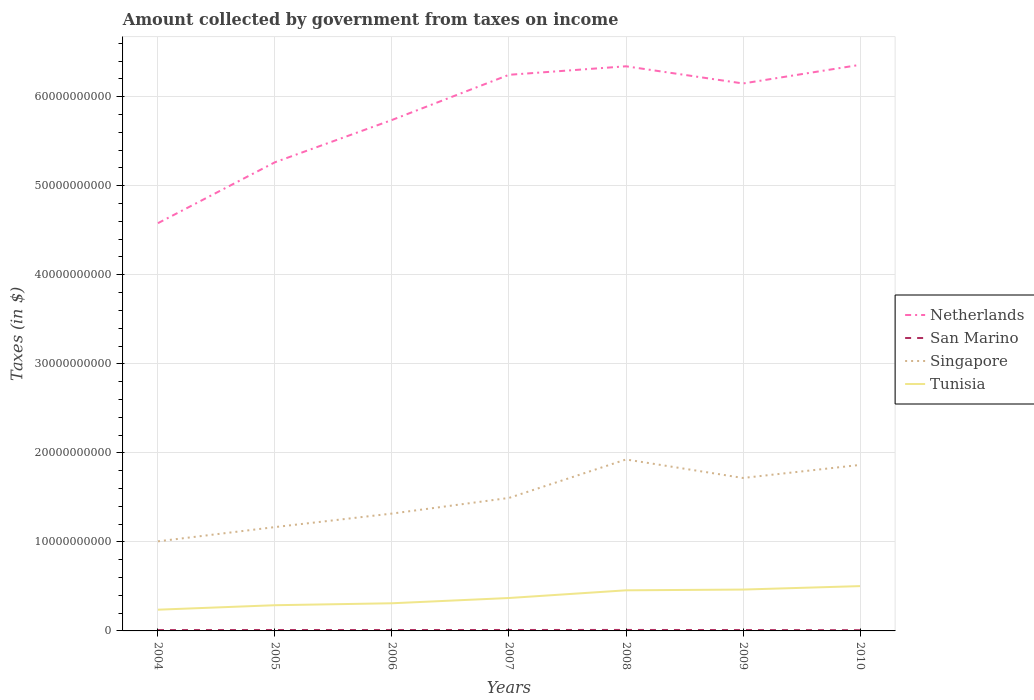Is the number of lines equal to the number of legend labels?
Your answer should be compact. Yes. Across all years, what is the maximum amount collected by government from taxes on income in Tunisia?
Your answer should be very brief. 2.39e+09. What is the total amount collected by government from taxes on income in Netherlands in the graph?
Keep it short and to the point. -9.55e+08. What is the difference between the highest and the second highest amount collected by government from taxes on income in Tunisia?
Make the answer very short. 2.65e+09. Is the amount collected by government from taxes on income in San Marino strictly greater than the amount collected by government from taxes on income in Tunisia over the years?
Your response must be concise. Yes. How many years are there in the graph?
Make the answer very short. 7. Are the values on the major ticks of Y-axis written in scientific E-notation?
Your answer should be compact. No. Does the graph contain any zero values?
Keep it short and to the point. No. How are the legend labels stacked?
Your response must be concise. Vertical. What is the title of the graph?
Offer a very short reply. Amount collected by government from taxes on income. Does "Vietnam" appear as one of the legend labels in the graph?
Your answer should be very brief. No. What is the label or title of the Y-axis?
Keep it short and to the point. Taxes (in $). What is the Taxes (in $) in Netherlands in 2004?
Offer a very short reply. 4.58e+1. What is the Taxes (in $) of San Marino in 2004?
Your answer should be compact. 9.60e+07. What is the Taxes (in $) in Singapore in 2004?
Offer a terse response. 1.01e+1. What is the Taxes (in $) in Tunisia in 2004?
Offer a very short reply. 2.39e+09. What is the Taxes (in $) in Netherlands in 2005?
Give a very brief answer. 5.26e+1. What is the Taxes (in $) of San Marino in 2005?
Ensure brevity in your answer.  1.02e+08. What is the Taxes (in $) of Singapore in 2005?
Your response must be concise. 1.17e+1. What is the Taxes (in $) in Tunisia in 2005?
Offer a terse response. 2.89e+09. What is the Taxes (in $) of Netherlands in 2006?
Give a very brief answer. 5.74e+1. What is the Taxes (in $) in San Marino in 2006?
Provide a short and direct response. 1.00e+08. What is the Taxes (in $) of Singapore in 2006?
Make the answer very short. 1.32e+1. What is the Taxes (in $) of Tunisia in 2006?
Make the answer very short. 3.11e+09. What is the Taxes (in $) in Netherlands in 2007?
Keep it short and to the point. 6.25e+1. What is the Taxes (in $) in San Marino in 2007?
Provide a succinct answer. 1.06e+08. What is the Taxes (in $) in Singapore in 2007?
Offer a very short reply. 1.49e+1. What is the Taxes (in $) of Tunisia in 2007?
Your answer should be very brief. 3.70e+09. What is the Taxes (in $) of Netherlands in 2008?
Ensure brevity in your answer.  6.34e+1. What is the Taxes (in $) in San Marino in 2008?
Offer a terse response. 1.09e+08. What is the Taxes (in $) in Singapore in 2008?
Ensure brevity in your answer.  1.93e+1. What is the Taxes (in $) in Tunisia in 2008?
Your answer should be compact. 4.56e+09. What is the Taxes (in $) in Netherlands in 2009?
Give a very brief answer. 6.15e+1. What is the Taxes (in $) of San Marino in 2009?
Make the answer very short. 9.80e+07. What is the Taxes (in $) in Singapore in 2009?
Offer a very short reply. 1.72e+1. What is the Taxes (in $) of Tunisia in 2009?
Offer a terse response. 4.65e+09. What is the Taxes (in $) in Netherlands in 2010?
Offer a very short reply. 6.36e+1. What is the Taxes (in $) in San Marino in 2010?
Provide a short and direct response. 8.28e+07. What is the Taxes (in $) in Singapore in 2010?
Provide a short and direct response. 1.86e+1. What is the Taxes (in $) of Tunisia in 2010?
Keep it short and to the point. 5.03e+09. Across all years, what is the maximum Taxes (in $) in Netherlands?
Keep it short and to the point. 6.36e+1. Across all years, what is the maximum Taxes (in $) in San Marino?
Your response must be concise. 1.09e+08. Across all years, what is the maximum Taxes (in $) in Singapore?
Give a very brief answer. 1.93e+1. Across all years, what is the maximum Taxes (in $) in Tunisia?
Offer a terse response. 5.03e+09. Across all years, what is the minimum Taxes (in $) of Netherlands?
Provide a succinct answer. 4.58e+1. Across all years, what is the minimum Taxes (in $) of San Marino?
Keep it short and to the point. 8.28e+07. Across all years, what is the minimum Taxes (in $) in Singapore?
Make the answer very short. 1.01e+1. Across all years, what is the minimum Taxes (in $) of Tunisia?
Your answer should be very brief. 2.39e+09. What is the total Taxes (in $) of Netherlands in the graph?
Make the answer very short. 4.07e+11. What is the total Taxes (in $) of San Marino in the graph?
Keep it short and to the point. 6.94e+08. What is the total Taxes (in $) of Singapore in the graph?
Provide a short and direct response. 1.05e+11. What is the total Taxes (in $) in Tunisia in the graph?
Make the answer very short. 2.63e+1. What is the difference between the Taxes (in $) of Netherlands in 2004 and that in 2005?
Give a very brief answer. -6.84e+09. What is the difference between the Taxes (in $) of San Marino in 2004 and that in 2005?
Your response must be concise. -5.80e+06. What is the difference between the Taxes (in $) in Singapore in 2004 and that in 2005?
Your answer should be compact. -1.60e+09. What is the difference between the Taxes (in $) of Tunisia in 2004 and that in 2005?
Make the answer very short. -5.01e+08. What is the difference between the Taxes (in $) of Netherlands in 2004 and that in 2006?
Your response must be concise. -1.16e+1. What is the difference between the Taxes (in $) of San Marino in 2004 and that in 2006?
Offer a very short reply. -4.31e+06. What is the difference between the Taxes (in $) in Singapore in 2004 and that in 2006?
Offer a very short reply. -3.12e+09. What is the difference between the Taxes (in $) in Tunisia in 2004 and that in 2006?
Your response must be concise. -7.22e+08. What is the difference between the Taxes (in $) of Netherlands in 2004 and that in 2007?
Keep it short and to the point. -1.67e+1. What is the difference between the Taxes (in $) of San Marino in 2004 and that in 2007?
Your answer should be compact. -9.60e+06. What is the difference between the Taxes (in $) in Singapore in 2004 and that in 2007?
Your answer should be compact. -4.88e+09. What is the difference between the Taxes (in $) in Tunisia in 2004 and that in 2007?
Ensure brevity in your answer.  -1.31e+09. What is the difference between the Taxes (in $) in Netherlands in 2004 and that in 2008?
Your answer should be compact. -1.76e+1. What is the difference between the Taxes (in $) in San Marino in 2004 and that in 2008?
Offer a very short reply. -1.32e+07. What is the difference between the Taxes (in $) in Singapore in 2004 and that in 2008?
Offer a very short reply. -9.19e+09. What is the difference between the Taxes (in $) in Tunisia in 2004 and that in 2008?
Keep it short and to the point. -2.18e+09. What is the difference between the Taxes (in $) of Netherlands in 2004 and that in 2009?
Provide a short and direct response. -1.57e+1. What is the difference between the Taxes (in $) in San Marino in 2004 and that in 2009?
Give a very brief answer. -2.04e+06. What is the difference between the Taxes (in $) of Singapore in 2004 and that in 2009?
Ensure brevity in your answer.  -7.12e+09. What is the difference between the Taxes (in $) of Tunisia in 2004 and that in 2009?
Your response must be concise. -2.26e+09. What is the difference between the Taxes (in $) in Netherlands in 2004 and that in 2010?
Your answer should be very brief. -1.78e+1. What is the difference between the Taxes (in $) of San Marino in 2004 and that in 2010?
Offer a very short reply. 1.31e+07. What is the difference between the Taxes (in $) of Singapore in 2004 and that in 2010?
Ensure brevity in your answer.  -8.58e+09. What is the difference between the Taxes (in $) in Tunisia in 2004 and that in 2010?
Your answer should be very brief. -2.65e+09. What is the difference between the Taxes (in $) in Netherlands in 2005 and that in 2006?
Your response must be concise. -4.75e+09. What is the difference between the Taxes (in $) of San Marino in 2005 and that in 2006?
Offer a terse response. 1.49e+06. What is the difference between the Taxes (in $) in Singapore in 2005 and that in 2006?
Provide a succinct answer. -1.52e+09. What is the difference between the Taxes (in $) in Tunisia in 2005 and that in 2006?
Make the answer very short. -2.20e+08. What is the difference between the Taxes (in $) in Netherlands in 2005 and that in 2007?
Offer a very short reply. -9.82e+09. What is the difference between the Taxes (in $) of San Marino in 2005 and that in 2007?
Provide a succinct answer. -3.79e+06. What is the difference between the Taxes (in $) of Singapore in 2005 and that in 2007?
Provide a succinct answer. -3.28e+09. What is the difference between the Taxes (in $) in Tunisia in 2005 and that in 2007?
Your answer should be compact. -8.12e+08. What is the difference between the Taxes (in $) in Netherlands in 2005 and that in 2008?
Provide a short and direct response. -1.08e+1. What is the difference between the Taxes (in $) of San Marino in 2005 and that in 2008?
Ensure brevity in your answer.  -7.45e+06. What is the difference between the Taxes (in $) of Singapore in 2005 and that in 2008?
Ensure brevity in your answer.  -7.59e+09. What is the difference between the Taxes (in $) of Tunisia in 2005 and that in 2008?
Offer a terse response. -1.67e+09. What is the difference between the Taxes (in $) of Netherlands in 2005 and that in 2009?
Make the answer very short. -8.85e+09. What is the difference between the Taxes (in $) in San Marino in 2005 and that in 2009?
Your response must be concise. 3.76e+06. What is the difference between the Taxes (in $) of Singapore in 2005 and that in 2009?
Provide a short and direct response. -5.52e+09. What is the difference between the Taxes (in $) in Tunisia in 2005 and that in 2009?
Ensure brevity in your answer.  -1.76e+09. What is the difference between the Taxes (in $) in Netherlands in 2005 and that in 2010?
Your answer should be compact. -1.09e+1. What is the difference between the Taxes (in $) of San Marino in 2005 and that in 2010?
Ensure brevity in your answer.  1.89e+07. What is the difference between the Taxes (in $) in Singapore in 2005 and that in 2010?
Your answer should be very brief. -6.98e+09. What is the difference between the Taxes (in $) in Tunisia in 2005 and that in 2010?
Keep it short and to the point. -2.15e+09. What is the difference between the Taxes (in $) of Netherlands in 2006 and that in 2007?
Keep it short and to the point. -5.07e+09. What is the difference between the Taxes (in $) of San Marino in 2006 and that in 2007?
Provide a short and direct response. -5.29e+06. What is the difference between the Taxes (in $) in Singapore in 2006 and that in 2007?
Provide a short and direct response. -1.76e+09. What is the difference between the Taxes (in $) of Tunisia in 2006 and that in 2007?
Make the answer very short. -5.91e+08. What is the difference between the Taxes (in $) of Netherlands in 2006 and that in 2008?
Provide a succinct answer. -6.03e+09. What is the difference between the Taxes (in $) of San Marino in 2006 and that in 2008?
Make the answer very short. -8.94e+06. What is the difference between the Taxes (in $) in Singapore in 2006 and that in 2008?
Your response must be concise. -6.08e+09. What is the difference between the Taxes (in $) in Tunisia in 2006 and that in 2008?
Provide a succinct answer. -1.45e+09. What is the difference between the Taxes (in $) of Netherlands in 2006 and that in 2009?
Provide a succinct answer. -4.10e+09. What is the difference between the Taxes (in $) in San Marino in 2006 and that in 2009?
Your answer should be compact. 2.27e+06. What is the difference between the Taxes (in $) of Singapore in 2006 and that in 2009?
Your response must be concise. -4.00e+09. What is the difference between the Taxes (in $) of Tunisia in 2006 and that in 2009?
Offer a terse response. -1.54e+09. What is the difference between the Taxes (in $) in Netherlands in 2006 and that in 2010?
Ensure brevity in your answer.  -6.19e+09. What is the difference between the Taxes (in $) of San Marino in 2006 and that in 2010?
Ensure brevity in your answer.  1.74e+07. What is the difference between the Taxes (in $) of Singapore in 2006 and that in 2010?
Your response must be concise. -5.46e+09. What is the difference between the Taxes (in $) in Tunisia in 2006 and that in 2010?
Your answer should be very brief. -1.93e+09. What is the difference between the Taxes (in $) of Netherlands in 2007 and that in 2008?
Your response must be concise. -9.55e+08. What is the difference between the Taxes (in $) in San Marino in 2007 and that in 2008?
Provide a short and direct response. -3.65e+06. What is the difference between the Taxes (in $) in Singapore in 2007 and that in 2008?
Provide a short and direct response. -4.32e+09. What is the difference between the Taxes (in $) of Tunisia in 2007 and that in 2008?
Keep it short and to the point. -8.63e+08. What is the difference between the Taxes (in $) of Netherlands in 2007 and that in 2009?
Offer a very short reply. 9.74e+08. What is the difference between the Taxes (in $) in San Marino in 2007 and that in 2009?
Give a very brief answer. 7.55e+06. What is the difference between the Taxes (in $) in Singapore in 2007 and that in 2009?
Your answer should be compact. -2.24e+09. What is the difference between the Taxes (in $) of Tunisia in 2007 and that in 2009?
Ensure brevity in your answer.  -9.48e+08. What is the difference between the Taxes (in $) in Netherlands in 2007 and that in 2010?
Provide a short and direct response. -1.12e+09. What is the difference between the Taxes (in $) of San Marino in 2007 and that in 2010?
Offer a very short reply. 2.27e+07. What is the difference between the Taxes (in $) of Singapore in 2007 and that in 2010?
Your answer should be very brief. -3.71e+09. What is the difference between the Taxes (in $) of Tunisia in 2007 and that in 2010?
Your answer should be compact. -1.34e+09. What is the difference between the Taxes (in $) in Netherlands in 2008 and that in 2009?
Keep it short and to the point. 1.93e+09. What is the difference between the Taxes (in $) of San Marino in 2008 and that in 2009?
Offer a very short reply. 1.12e+07. What is the difference between the Taxes (in $) in Singapore in 2008 and that in 2009?
Give a very brief answer. 2.08e+09. What is the difference between the Taxes (in $) in Tunisia in 2008 and that in 2009?
Ensure brevity in your answer.  -8.46e+07. What is the difference between the Taxes (in $) in Netherlands in 2008 and that in 2010?
Make the answer very short. -1.63e+08. What is the difference between the Taxes (in $) in San Marino in 2008 and that in 2010?
Offer a terse response. 2.64e+07. What is the difference between the Taxes (in $) of Singapore in 2008 and that in 2010?
Give a very brief answer. 6.11e+08. What is the difference between the Taxes (in $) of Tunisia in 2008 and that in 2010?
Provide a succinct answer. -4.72e+08. What is the difference between the Taxes (in $) in Netherlands in 2009 and that in 2010?
Provide a short and direct response. -2.09e+09. What is the difference between the Taxes (in $) of San Marino in 2009 and that in 2010?
Your response must be concise. 1.52e+07. What is the difference between the Taxes (in $) in Singapore in 2009 and that in 2010?
Offer a very short reply. -1.47e+09. What is the difference between the Taxes (in $) in Tunisia in 2009 and that in 2010?
Give a very brief answer. -3.87e+08. What is the difference between the Taxes (in $) of Netherlands in 2004 and the Taxes (in $) of San Marino in 2005?
Keep it short and to the point. 4.57e+1. What is the difference between the Taxes (in $) in Netherlands in 2004 and the Taxes (in $) in Singapore in 2005?
Offer a very short reply. 3.41e+1. What is the difference between the Taxes (in $) in Netherlands in 2004 and the Taxes (in $) in Tunisia in 2005?
Give a very brief answer. 4.29e+1. What is the difference between the Taxes (in $) of San Marino in 2004 and the Taxes (in $) of Singapore in 2005?
Your answer should be compact. -1.16e+1. What is the difference between the Taxes (in $) in San Marino in 2004 and the Taxes (in $) in Tunisia in 2005?
Your answer should be compact. -2.79e+09. What is the difference between the Taxes (in $) of Singapore in 2004 and the Taxes (in $) of Tunisia in 2005?
Keep it short and to the point. 7.18e+09. What is the difference between the Taxes (in $) of Netherlands in 2004 and the Taxes (in $) of San Marino in 2006?
Provide a succinct answer. 4.57e+1. What is the difference between the Taxes (in $) in Netherlands in 2004 and the Taxes (in $) in Singapore in 2006?
Offer a very short reply. 3.26e+1. What is the difference between the Taxes (in $) in Netherlands in 2004 and the Taxes (in $) in Tunisia in 2006?
Offer a terse response. 4.27e+1. What is the difference between the Taxes (in $) of San Marino in 2004 and the Taxes (in $) of Singapore in 2006?
Your answer should be very brief. -1.31e+1. What is the difference between the Taxes (in $) of San Marino in 2004 and the Taxes (in $) of Tunisia in 2006?
Provide a short and direct response. -3.01e+09. What is the difference between the Taxes (in $) in Singapore in 2004 and the Taxes (in $) in Tunisia in 2006?
Provide a short and direct response. 6.96e+09. What is the difference between the Taxes (in $) in Netherlands in 2004 and the Taxes (in $) in San Marino in 2007?
Your response must be concise. 4.57e+1. What is the difference between the Taxes (in $) of Netherlands in 2004 and the Taxes (in $) of Singapore in 2007?
Your answer should be compact. 3.09e+1. What is the difference between the Taxes (in $) of Netherlands in 2004 and the Taxes (in $) of Tunisia in 2007?
Offer a very short reply. 4.21e+1. What is the difference between the Taxes (in $) in San Marino in 2004 and the Taxes (in $) in Singapore in 2007?
Your response must be concise. -1.48e+1. What is the difference between the Taxes (in $) in San Marino in 2004 and the Taxes (in $) in Tunisia in 2007?
Your answer should be very brief. -3.60e+09. What is the difference between the Taxes (in $) of Singapore in 2004 and the Taxes (in $) of Tunisia in 2007?
Give a very brief answer. 6.37e+09. What is the difference between the Taxes (in $) in Netherlands in 2004 and the Taxes (in $) in San Marino in 2008?
Offer a terse response. 4.57e+1. What is the difference between the Taxes (in $) in Netherlands in 2004 and the Taxes (in $) in Singapore in 2008?
Give a very brief answer. 2.65e+1. What is the difference between the Taxes (in $) in Netherlands in 2004 and the Taxes (in $) in Tunisia in 2008?
Make the answer very short. 4.12e+1. What is the difference between the Taxes (in $) of San Marino in 2004 and the Taxes (in $) of Singapore in 2008?
Provide a succinct answer. -1.92e+1. What is the difference between the Taxes (in $) in San Marino in 2004 and the Taxes (in $) in Tunisia in 2008?
Ensure brevity in your answer.  -4.46e+09. What is the difference between the Taxes (in $) in Singapore in 2004 and the Taxes (in $) in Tunisia in 2008?
Ensure brevity in your answer.  5.50e+09. What is the difference between the Taxes (in $) in Netherlands in 2004 and the Taxes (in $) in San Marino in 2009?
Offer a terse response. 4.57e+1. What is the difference between the Taxes (in $) in Netherlands in 2004 and the Taxes (in $) in Singapore in 2009?
Your answer should be very brief. 2.86e+1. What is the difference between the Taxes (in $) of Netherlands in 2004 and the Taxes (in $) of Tunisia in 2009?
Your answer should be compact. 4.12e+1. What is the difference between the Taxes (in $) of San Marino in 2004 and the Taxes (in $) of Singapore in 2009?
Give a very brief answer. -1.71e+1. What is the difference between the Taxes (in $) in San Marino in 2004 and the Taxes (in $) in Tunisia in 2009?
Ensure brevity in your answer.  -4.55e+09. What is the difference between the Taxes (in $) in Singapore in 2004 and the Taxes (in $) in Tunisia in 2009?
Give a very brief answer. 5.42e+09. What is the difference between the Taxes (in $) in Netherlands in 2004 and the Taxes (in $) in San Marino in 2010?
Provide a succinct answer. 4.57e+1. What is the difference between the Taxes (in $) of Netherlands in 2004 and the Taxes (in $) of Singapore in 2010?
Offer a very short reply. 2.72e+1. What is the difference between the Taxes (in $) of Netherlands in 2004 and the Taxes (in $) of Tunisia in 2010?
Provide a short and direct response. 4.08e+1. What is the difference between the Taxes (in $) in San Marino in 2004 and the Taxes (in $) in Singapore in 2010?
Provide a short and direct response. -1.85e+1. What is the difference between the Taxes (in $) in San Marino in 2004 and the Taxes (in $) in Tunisia in 2010?
Offer a very short reply. -4.94e+09. What is the difference between the Taxes (in $) of Singapore in 2004 and the Taxes (in $) of Tunisia in 2010?
Give a very brief answer. 5.03e+09. What is the difference between the Taxes (in $) in Netherlands in 2005 and the Taxes (in $) in San Marino in 2006?
Give a very brief answer. 5.25e+1. What is the difference between the Taxes (in $) in Netherlands in 2005 and the Taxes (in $) in Singapore in 2006?
Provide a succinct answer. 3.95e+1. What is the difference between the Taxes (in $) of Netherlands in 2005 and the Taxes (in $) of Tunisia in 2006?
Keep it short and to the point. 4.95e+1. What is the difference between the Taxes (in $) of San Marino in 2005 and the Taxes (in $) of Singapore in 2006?
Make the answer very short. -1.31e+1. What is the difference between the Taxes (in $) in San Marino in 2005 and the Taxes (in $) in Tunisia in 2006?
Offer a very short reply. -3.00e+09. What is the difference between the Taxes (in $) in Singapore in 2005 and the Taxes (in $) in Tunisia in 2006?
Your answer should be very brief. 8.56e+09. What is the difference between the Taxes (in $) of Netherlands in 2005 and the Taxes (in $) of San Marino in 2007?
Keep it short and to the point. 5.25e+1. What is the difference between the Taxes (in $) of Netherlands in 2005 and the Taxes (in $) of Singapore in 2007?
Ensure brevity in your answer.  3.77e+1. What is the difference between the Taxes (in $) in Netherlands in 2005 and the Taxes (in $) in Tunisia in 2007?
Your answer should be very brief. 4.89e+1. What is the difference between the Taxes (in $) in San Marino in 2005 and the Taxes (in $) in Singapore in 2007?
Offer a very short reply. -1.48e+1. What is the difference between the Taxes (in $) in San Marino in 2005 and the Taxes (in $) in Tunisia in 2007?
Your answer should be compact. -3.60e+09. What is the difference between the Taxes (in $) in Singapore in 2005 and the Taxes (in $) in Tunisia in 2007?
Keep it short and to the point. 7.97e+09. What is the difference between the Taxes (in $) in Netherlands in 2005 and the Taxes (in $) in San Marino in 2008?
Keep it short and to the point. 5.25e+1. What is the difference between the Taxes (in $) of Netherlands in 2005 and the Taxes (in $) of Singapore in 2008?
Keep it short and to the point. 3.34e+1. What is the difference between the Taxes (in $) in Netherlands in 2005 and the Taxes (in $) in Tunisia in 2008?
Give a very brief answer. 4.81e+1. What is the difference between the Taxes (in $) of San Marino in 2005 and the Taxes (in $) of Singapore in 2008?
Offer a very short reply. -1.92e+1. What is the difference between the Taxes (in $) in San Marino in 2005 and the Taxes (in $) in Tunisia in 2008?
Offer a very short reply. -4.46e+09. What is the difference between the Taxes (in $) of Singapore in 2005 and the Taxes (in $) of Tunisia in 2008?
Offer a very short reply. 7.10e+09. What is the difference between the Taxes (in $) in Netherlands in 2005 and the Taxes (in $) in San Marino in 2009?
Ensure brevity in your answer.  5.25e+1. What is the difference between the Taxes (in $) in Netherlands in 2005 and the Taxes (in $) in Singapore in 2009?
Provide a short and direct response. 3.55e+1. What is the difference between the Taxes (in $) of Netherlands in 2005 and the Taxes (in $) of Tunisia in 2009?
Make the answer very short. 4.80e+1. What is the difference between the Taxes (in $) of San Marino in 2005 and the Taxes (in $) of Singapore in 2009?
Your response must be concise. -1.71e+1. What is the difference between the Taxes (in $) of San Marino in 2005 and the Taxes (in $) of Tunisia in 2009?
Your answer should be compact. -4.54e+09. What is the difference between the Taxes (in $) in Singapore in 2005 and the Taxes (in $) in Tunisia in 2009?
Give a very brief answer. 7.02e+09. What is the difference between the Taxes (in $) in Netherlands in 2005 and the Taxes (in $) in San Marino in 2010?
Your answer should be compact. 5.26e+1. What is the difference between the Taxes (in $) in Netherlands in 2005 and the Taxes (in $) in Singapore in 2010?
Offer a terse response. 3.40e+1. What is the difference between the Taxes (in $) of Netherlands in 2005 and the Taxes (in $) of Tunisia in 2010?
Provide a short and direct response. 4.76e+1. What is the difference between the Taxes (in $) in San Marino in 2005 and the Taxes (in $) in Singapore in 2010?
Provide a short and direct response. -1.85e+1. What is the difference between the Taxes (in $) of San Marino in 2005 and the Taxes (in $) of Tunisia in 2010?
Give a very brief answer. -4.93e+09. What is the difference between the Taxes (in $) in Singapore in 2005 and the Taxes (in $) in Tunisia in 2010?
Provide a succinct answer. 6.63e+09. What is the difference between the Taxes (in $) in Netherlands in 2006 and the Taxes (in $) in San Marino in 2007?
Offer a terse response. 5.73e+1. What is the difference between the Taxes (in $) in Netherlands in 2006 and the Taxes (in $) in Singapore in 2007?
Make the answer very short. 4.25e+1. What is the difference between the Taxes (in $) in Netherlands in 2006 and the Taxes (in $) in Tunisia in 2007?
Make the answer very short. 5.37e+1. What is the difference between the Taxes (in $) in San Marino in 2006 and the Taxes (in $) in Singapore in 2007?
Offer a terse response. -1.48e+1. What is the difference between the Taxes (in $) of San Marino in 2006 and the Taxes (in $) of Tunisia in 2007?
Keep it short and to the point. -3.60e+09. What is the difference between the Taxes (in $) of Singapore in 2006 and the Taxes (in $) of Tunisia in 2007?
Make the answer very short. 9.48e+09. What is the difference between the Taxes (in $) of Netherlands in 2006 and the Taxes (in $) of San Marino in 2008?
Make the answer very short. 5.73e+1. What is the difference between the Taxes (in $) of Netherlands in 2006 and the Taxes (in $) of Singapore in 2008?
Offer a very short reply. 3.81e+1. What is the difference between the Taxes (in $) of Netherlands in 2006 and the Taxes (in $) of Tunisia in 2008?
Provide a short and direct response. 5.28e+1. What is the difference between the Taxes (in $) in San Marino in 2006 and the Taxes (in $) in Singapore in 2008?
Your answer should be very brief. -1.92e+1. What is the difference between the Taxes (in $) in San Marino in 2006 and the Taxes (in $) in Tunisia in 2008?
Offer a very short reply. -4.46e+09. What is the difference between the Taxes (in $) in Singapore in 2006 and the Taxes (in $) in Tunisia in 2008?
Offer a very short reply. 8.62e+09. What is the difference between the Taxes (in $) of Netherlands in 2006 and the Taxes (in $) of San Marino in 2009?
Offer a terse response. 5.73e+1. What is the difference between the Taxes (in $) in Netherlands in 2006 and the Taxes (in $) in Singapore in 2009?
Give a very brief answer. 4.02e+1. What is the difference between the Taxes (in $) in Netherlands in 2006 and the Taxes (in $) in Tunisia in 2009?
Offer a very short reply. 5.27e+1. What is the difference between the Taxes (in $) of San Marino in 2006 and the Taxes (in $) of Singapore in 2009?
Make the answer very short. -1.71e+1. What is the difference between the Taxes (in $) of San Marino in 2006 and the Taxes (in $) of Tunisia in 2009?
Your response must be concise. -4.55e+09. What is the difference between the Taxes (in $) in Singapore in 2006 and the Taxes (in $) in Tunisia in 2009?
Offer a very short reply. 8.54e+09. What is the difference between the Taxes (in $) of Netherlands in 2006 and the Taxes (in $) of San Marino in 2010?
Your answer should be compact. 5.73e+1. What is the difference between the Taxes (in $) of Netherlands in 2006 and the Taxes (in $) of Singapore in 2010?
Keep it short and to the point. 3.87e+1. What is the difference between the Taxes (in $) in Netherlands in 2006 and the Taxes (in $) in Tunisia in 2010?
Make the answer very short. 5.24e+1. What is the difference between the Taxes (in $) in San Marino in 2006 and the Taxes (in $) in Singapore in 2010?
Make the answer very short. -1.85e+1. What is the difference between the Taxes (in $) of San Marino in 2006 and the Taxes (in $) of Tunisia in 2010?
Provide a short and direct response. -4.93e+09. What is the difference between the Taxes (in $) of Singapore in 2006 and the Taxes (in $) of Tunisia in 2010?
Your answer should be very brief. 8.15e+09. What is the difference between the Taxes (in $) in Netherlands in 2007 and the Taxes (in $) in San Marino in 2008?
Your answer should be compact. 6.24e+1. What is the difference between the Taxes (in $) in Netherlands in 2007 and the Taxes (in $) in Singapore in 2008?
Your answer should be compact. 4.32e+1. What is the difference between the Taxes (in $) in Netherlands in 2007 and the Taxes (in $) in Tunisia in 2008?
Give a very brief answer. 5.79e+1. What is the difference between the Taxes (in $) of San Marino in 2007 and the Taxes (in $) of Singapore in 2008?
Give a very brief answer. -1.92e+1. What is the difference between the Taxes (in $) of San Marino in 2007 and the Taxes (in $) of Tunisia in 2008?
Give a very brief answer. -4.46e+09. What is the difference between the Taxes (in $) of Singapore in 2007 and the Taxes (in $) of Tunisia in 2008?
Your answer should be very brief. 1.04e+1. What is the difference between the Taxes (in $) in Netherlands in 2007 and the Taxes (in $) in San Marino in 2009?
Your answer should be very brief. 6.24e+1. What is the difference between the Taxes (in $) of Netherlands in 2007 and the Taxes (in $) of Singapore in 2009?
Your response must be concise. 4.53e+1. What is the difference between the Taxes (in $) in Netherlands in 2007 and the Taxes (in $) in Tunisia in 2009?
Offer a terse response. 5.78e+1. What is the difference between the Taxes (in $) in San Marino in 2007 and the Taxes (in $) in Singapore in 2009?
Your answer should be compact. -1.71e+1. What is the difference between the Taxes (in $) in San Marino in 2007 and the Taxes (in $) in Tunisia in 2009?
Offer a terse response. -4.54e+09. What is the difference between the Taxes (in $) of Singapore in 2007 and the Taxes (in $) of Tunisia in 2009?
Provide a short and direct response. 1.03e+1. What is the difference between the Taxes (in $) of Netherlands in 2007 and the Taxes (in $) of San Marino in 2010?
Make the answer very short. 6.24e+1. What is the difference between the Taxes (in $) in Netherlands in 2007 and the Taxes (in $) in Singapore in 2010?
Make the answer very short. 4.38e+1. What is the difference between the Taxes (in $) of Netherlands in 2007 and the Taxes (in $) of Tunisia in 2010?
Make the answer very short. 5.74e+1. What is the difference between the Taxes (in $) in San Marino in 2007 and the Taxes (in $) in Singapore in 2010?
Offer a very short reply. -1.85e+1. What is the difference between the Taxes (in $) in San Marino in 2007 and the Taxes (in $) in Tunisia in 2010?
Give a very brief answer. -4.93e+09. What is the difference between the Taxes (in $) of Singapore in 2007 and the Taxes (in $) of Tunisia in 2010?
Give a very brief answer. 9.91e+09. What is the difference between the Taxes (in $) of Netherlands in 2008 and the Taxes (in $) of San Marino in 2009?
Provide a succinct answer. 6.33e+1. What is the difference between the Taxes (in $) of Netherlands in 2008 and the Taxes (in $) of Singapore in 2009?
Keep it short and to the point. 4.62e+1. What is the difference between the Taxes (in $) in Netherlands in 2008 and the Taxes (in $) in Tunisia in 2009?
Your response must be concise. 5.88e+1. What is the difference between the Taxes (in $) in San Marino in 2008 and the Taxes (in $) in Singapore in 2009?
Offer a terse response. -1.71e+1. What is the difference between the Taxes (in $) of San Marino in 2008 and the Taxes (in $) of Tunisia in 2009?
Ensure brevity in your answer.  -4.54e+09. What is the difference between the Taxes (in $) of Singapore in 2008 and the Taxes (in $) of Tunisia in 2009?
Your answer should be compact. 1.46e+1. What is the difference between the Taxes (in $) in Netherlands in 2008 and the Taxes (in $) in San Marino in 2010?
Your answer should be compact. 6.33e+1. What is the difference between the Taxes (in $) of Netherlands in 2008 and the Taxes (in $) of Singapore in 2010?
Ensure brevity in your answer.  4.48e+1. What is the difference between the Taxes (in $) of Netherlands in 2008 and the Taxes (in $) of Tunisia in 2010?
Your response must be concise. 5.84e+1. What is the difference between the Taxes (in $) in San Marino in 2008 and the Taxes (in $) in Singapore in 2010?
Offer a terse response. -1.85e+1. What is the difference between the Taxes (in $) in San Marino in 2008 and the Taxes (in $) in Tunisia in 2010?
Keep it short and to the point. -4.92e+09. What is the difference between the Taxes (in $) of Singapore in 2008 and the Taxes (in $) of Tunisia in 2010?
Your answer should be very brief. 1.42e+1. What is the difference between the Taxes (in $) in Netherlands in 2009 and the Taxes (in $) in San Marino in 2010?
Your response must be concise. 6.14e+1. What is the difference between the Taxes (in $) in Netherlands in 2009 and the Taxes (in $) in Singapore in 2010?
Provide a succinct answer. 4.28e+1. What is the difference between the Taxes (in $) of Netherlands in 2009 and the Taxes (in $) of Tunisia in 2010?
Ensure brevity in your answer.  5.65e+1. What is the difference between the Taxes (in $) of San Marino in 2009 and the Taxes (in $) of Singapore in 2010?
Your response must be concise. -1.85e+1. What is the difference between the Taxes (in $) in San Marino in 2009 and the Taxes (in $) in Tunisia in 2010?
Offer a terse response. -4.93e+09. What is the difference between the Taxes (in $) in Singapore in 2009 and the Taxes (in $) in Tunisia in 2010?
Make the answer very short. 1.21e+1. What is the average Taxes (in $) in Netherlands per year?
Your response must be concise. 5.81e+1. What is the average Taxes (in $) of San Marino per year?
Offer a terse response. 9.91e+07. What is the average Taxes (in $) of Singapore per year?
Your answer should be compact. 1.50e+1. What is the average Taxes (in $) of Tunisia per year?
Give a very brief answer. 3.76e+09. In the year 2004, what is the difference between the Taxes (in $) of Netherlands and Taxes (in $) of San Marino?
Provide a short and direct response. 4.57e+1. In the year 2004, what is the difference between the Taxes (in $) in Netherlands and Taxes (in $) in Singapore?
Ensure brevity in your answer.  3.57e+1. In the year 2004, what is the difference between the Taxes (in $) in Netherlands and Taxes (in $) in Tunisia?
Provide a short and direct response. 4.34e+1. In the year 2004, what is the difference between the Taxes (in $) in San Marino and Taxes (in $) in Singapore?
Provide a short and direct response. -9.97e+09. In the year 2004, what is the difference between the Taxes (in $) in San Marino and Taxes (in $) in Tunisia?
Provide a short and direct response. -2.29e+09. In the year 2004, what is the difference between the Taxes (in $) of Singapore and Taxes (in $) of Tunisia?
Provide a succinct answer. 7.68e+09. In the year 2005, what is the difference between the Taxes (in $) in Netherlands and Taxes (in $) in San Marino?
Your response must be concise. 5.25e+1. In the year 2005, what is the difference between the Taxes (in $) of Netherlands and Taxes (in $) of Singapore?
Give a very brief answer. 4.10e+1. In the year 2005, what is the difference between the Taxes (in $) in Netherlands and Taxes (in $) in Tunisia?
Keep it short and to the point. 4.98e+1. In the year 2005, what is the difference between the Taxes (in $) in San Marino and Taxes (in $) in Singapore?
Your answer should be very brief. -1.16e+1. In the year 2005, what is the difference between the Taxes (in $) in San Marino and Taxes (in $) in Tunisia?
Provide a short and direct response. -2.78e+09. In the year 2005, what is the difference between the Taxes (in $) in Singapore and Taxes (in $) in Tunisia?
Your answer should be very brief. 8.78e+09. In the year 2006, what is the difference between the Taxes (in $) in Netherlands and Taxes (in $) in San Marino?
Offer a very short reply. 5.73e+1. In the year 2006, what is the difference between the Taxes (in $) of Netherlands and Taxes (in $) of Singapore?
Make the answer very short. 4.42e+1. In the year 2006, what is the difference between the Taxes (in $) of Netherlands and Taxes (in $) of Tunisia?
Provide a short and direct response. 5.43e+1. In the year 2006, what is the difference between the Taxes (in $) of San Marino and Taxes (in $) of Singapore?
Provide a short and direct response. -1.31e+1. In the year 2006, what is the difference between the Taxes (in $) of San Marino and Taxes (in $) of Tunisia?
Your response must be concise. -3.01e+09. In the year 2006, what is the difference between the Taxes (in $) in Singapore and Taxes (in $) in Tunisia?
Keep it short and to the point. 1.01e+1. In the year 2007, what is the difference between the Taxes (in $) in Netherlands and Taxes (in $) in San Marino?
Provide a short and direct response. 6.24e+1. In the year 2007, what is the difference between the Taxes (in $) of Netherlands and Taxes (in $) of Singapore?
Keep it short and to the point. 4.75e+1. In the year 2007, what is the difference between the Taxes (in $) of Netherlands and Taxes (in $) of Tunisia?
Provide a succinct answer. 5.88e+1. In the year 2007, what is the difference between the Taxes (in $) in San Marino and Taxes (in $) in Singapore?
Make the answer very short. -1.48e+1. In the year 2007, what is the difference between the Taxes (in $) of San Marino and Taxes (in $) of Tunisia?
Keep it short and to the point. -3.59e+09. In the year 2007, what is the difference between the Taxes (in $) in Singapore and Taxes (in $) in Tunisia?
Offer a terse response. 1.12e+1. In the year 2008, what is the difference between the Taxes (in $) of Netherlands and Taxes (in $) of San Marino?
Provide a succinct answer. 6.33e+1. In the year 2008, what is the difference between the Taxes (in $) in Netherlands and Taxes (in $) in Singapore?
Ensure brevity in your answer.  4.42e+1. In the year 2008, what is the difference between the Taxes (in $) of Netherlands and Taxes (in $) of Tunisia?
Your answer should be very brief. 5.89e+1. In the year 2008, what is the difference between the Taxes (in $) in San Marino and Taxes (in $) in Singapore?
Your answer should be very brief. -1.91e+1. In the year 2008, what is the difference between the Taxes (in $) in San Marino and Taxes (in $) in Tunisia?
Keep it short and to the point. -4.45e+09. In the year 2008, what is the difference between the Taxes (in $) of Singapore and Taxes (in $) of Tunisia?
Make the answer very short. 1.47e+1. In the year 2009, what is the difference between the Taxes (in $) in Netherlands and Taxes (in $) in San Marino?
Your answer should be very brief. 6.14e+1. In the year 2009, what is the difference between the Taxes (in $) of Netherlands and Taxes (in $) of Singapore?
Ensure brevity in your answer.  4.43e+1. In the year 2009, what is the difference between the Taxes (in $) of Netherlands and Taxes (in $) of Tunisia?
Your answer should be very brief. 5.68e+1. In the year 2009, what is the difference between the Taxes (in $) in San Marino and Taxes (in $) in Singapore?
Your answer should be compact. -1.71e+1. In the year 2009, what is the difference between the Taxes (in $) of San Marino and Taxes (in $) of Tunisia?
Make the answer very short. -4.55e+09. In the year 2009, what is the difference between the Taxes (in $) of Singapore and Taxes (in $) of Tunisia?
Keep it short and to the point. 1.25e+1. In the year 2010, what is the difference between the Taxes (in $) of Netherlands and Taxes (in $) of San Marino?
Keep it short and to the point. 6.35e+1. In the year 2010, what is the difference between the Taxes (in $) in Netherlands and Taxes (in $) in Singapore?
Provide a succinct answer. 4.49e+1. In the year 2010, what is the difference between the Taxes (in $) of Netherlands and Taxes (in $) of Tunisia?
Offer a very short reply. 5.85e+1. In the year 2010, what is the difference between the Taxes (in $) in San Marino and Taxes (in $) in Singapore?
Offer a terse response. -1.86e+1. In the year 2010, what is the difference between the Taxes (in $) in San Marino and Taxes (in $) in Tunisia?
Ensure brevity in your answer.  -4.95e+09. In the year 2010, what is the difference between the Taxes (in $) in Singapore and Taxes (in $) in Tunisia?
Ensure brevity in your answer.  1.36e+1. What is the ratio of the Taxes (in $) in Netherlands in 2004 to that in 2005?
Ensure brevity in your answer.  0.87. What is the ratio of the Taxes (in $) in San Marino in 2004 to that in 2005?
Ensure brevity in your answer.  0.94. What is the ratio of the Taxes (in $) of Singapore in 2004 to that in 2005?
Your answer should be very brief. 0.86. What is the ratio of the Taxes (in $) of Tunisia in 2004 to that in 2005?
Your response must be concise. 0.83. What is the ratio of the Taxes (in $) of Netherlands in 2004 to that in 2006?
Keep it short and to the point. 0.8. What is the ratio of the Taxes (in $) in Singapore in 2004 to that in 2006?
Your response must be concise. 0.76. What is the ratio of the Taxes (in $) of Tunisia in 2004 to that in 2006?
Offer a terse response. 0.77. What is the ratio of the Taxes (in $) in Netherlands in 2004 to that in 2007?
Offer a terse response. 0.73. What is the ratio of the Taxes (in $) of San Marino in 2004 to that in 2007?
Offer a terse response. 0.91. What is the ratio of the Taxes (in $) in Singapore in 2004 to that in 2007?
Keep it short and to the point. 0.67. What is the ratio of the Taxes (in $) in Tunisia in 2004 to that in 2007?
Provide a succinct answer. 0.65. What is the ratio of the Taxes (in $) in Netherlands in 2004 to that in 2008?
Keep it short and to the point. 0.72. What is the ratio of the Taxes (in $) in San Marino in 2004 to that in 2008?
Your response must be concise. 0.88. What is the ratio of the Taxes (in $) of Singapore in 2004 to that in 2008?
Provide a succinct answer. 0.52. What is the ratio of the Taxes (in $) of Tunisia in 2004 to that in 2008?
Give a very brief answer. 0.52. What is the ratio of the Taxes (in $) of Netherlands in 2004 to that in 2009?
Offer a very short reply. 0.74. What is the ratio of the Taxes (in $) of San Marino in 2004 to that in 2009?
Your answer should be very brief. 0.98. What is the ratio of the Taxes (in $) of Singapore in 2004 to that in 2009?
Offer a terse response. 0.59. What is the ratio of the Taxes (in $) in Tunisia in 2004 to that in 2009?
Offer a very short reply. 0.51. What is the ratio of the Taxes (in $) of Netherlands in 2004 to that in 2010?
Your answer should be very brief. 0.72. What is the ratio of the Taxes (in $) of San Marino in 2004 to that in 2010?
Give a very brief answer. 1.16. What is the ratio of the Taxes (in $) in Singapore in 2004 to that in 2010?
Make the answer very short. 0.54. What is the ratio of the Taxes (in $) in Tunisia in 2004 to that in 2010?
Provide a succinct answer. 0.47. What is the ratio of the Taxes (in $) of Netherlands in 2005 to that in 2006?
Your answer should be compact. 0.92. What is the ratio of the Taxes (in $) in San Marino in 2005 to that in 2006?
Offer a very short reply. 1.01. What is the ratio of the Taxes (in $) in Singapore in 2005 to that in 2006?
Offer a terse response. 0.88. What is the ratio of the Taxes (in $) of Tunisia in 2005 to that in 2006?
Offer a terse response. 0.93. What is the ratio of the Taxes (in $) in Netherlands in 2005 to that in 2007?
Your answer should be very brief. 0.84. What is the ratio of the Taxes (in $) of Singapore in 2005 to that in 2007?
Your answer should be very brief. 0.78. What is the ratio of the Taxes (in $) in Tunisia in 2005 to that in 2007?
Provide a short and direct response. 0.78. What is the ratio of the Taxes (in $) of Netherlands in 2005 to that in 2008?
Offer a very short reply. 0.83. What is the ratio of the Taxes (in $) of San Marino in 2005 to that in 2008?
Keep it short and to the point. 0.93. What is the ratio of the Taxes (in $) of Singapore in 2005 to that in 2008?
Provide a short and direct response. 0.61. What is the ratio of the Taxes (in $) of Tunisia in 2005 to that in 2008?
Provide a short and direct response. 0.63. What is the ratio of the Taxes (in $) in Netherlands in 2005 to that in 2009?
Provide a short and direct response. 0.86. What is the ratio of the Taxes (in $) of San Marino in 2005 to that in 2009?
Your answer should be very brief. 1.04. What is the ratio of the Taxes (in $) of Singapore in 2005 to that in 2009?
Offer a terse response. 0.68. What is the ratio of the Taxes (in $) in Tunisia in 2005 to that in 2009?
Offer a very short reply. 0.62. What is the ratio of the Taxes (in $) in Netherlands in 2005 to that in 2010?
Offer a very short reply. 0.83. What is the ratio of the Taxes (in $) in San Marino in 2005 to that in 2010?
Offer a terse response. 1.23. What is the ratio of the Taxes (in $) of Singapore in 2005 to that in 2010?
Your answer should be compact. 0.63. What is the ratio of the Taxes (in $) of Tunisia in 2005 to that in 2010?
Your answer should be very brief. 0.57. What is the ratio of the Taxes (in $) in Netherlands in 2006 to that in 2007?
Provide a short and direct response. 0.92. What is the ratio of the Taxes (in $) of San Marino in 2006 to that in 2007?
Offer a terse response. 0.95. What is the ratio of the Taxes (in $) of Singapore in 2006 to that in 2007?
Offer a very short reply. 0.88. What is the ratio of the Taxes (in $) of Tunisia in 2006 to that in 2007?
Offer a terse response. 0.84. What is the ratio of the Taxes (in $) in Netherlands in 2006 to that in 2008?
Keep it short and to the point. 0.9. What is the ratio of the Taxes (in $) in San Marino in 2006 to that in 2008?
Ensure brevity in your answer.  0.92. What is the ratio of the Taxes (in $) of Singapore in 2006 to that in 2008?
Keep it short and to the point. 0.68. What is the ratio of the Taxes (in $) of Tunisia in 2006 to that in 2008?
Your answer should be very brief. 0.68. What is the ratio of the Taxes (in $) in Netherlands in 2006 to that in 2009?
Keep it short and to the point. 0.93. What is the ratio of the Taxes (in $) in San Marino in 2006 to that in 2009?
Ensure brevity in your answer.  1.02. What is the ratio of the Taxes (in $) of Singapore in 2006 to that in 2009?
Give a very brief answer. 0.77. What is the ratio of the Taxes (in $) of Tunisia in 2006 to that in 2009?
Ensure brevity in your answer.  0.67. What is the ratio of the Taxes (in $) in Netherlands in 2006 to that in 2010?
Your answer should be very brief. 0.9. What is the ratio of the Taxes (in $) in San Marino in 2006 to that in 2010?
Offer a very short reply. 1.21. What is the ratio of the Taxes (in $) in Singapore in 2006 to that in 2010?
Ensure brevity in your answer.  0.71. What is the ratio of the Taxes (in $) of Tunisia in 2006 to that in 2010?
Offer a terse response. 0.62. What is the ratio of the Taxes (in $) of Netherlands in 2007 to that in 2008?
Your answer should be compact. 0.98. What is the ratio of the Taxes (in $) of San Marino in 2007 to that in 2008?
Provide a short and direct response. 0.97. What is the ratio of the Taxes (in $) in Singapore in 2007 to that in 2008?
Provide a succinct answer. 0.78. What is the ratio of the Taxes (in $) in Tunisia in 2007 to that in 2008?
Offer a terse response. 0.81. What is the ratio of the Taxes (in $) in Netherlands in 2007 to that in 2009?
Ensure brevity in your answer.  1.02. What is the ratio of the Taxes (in $) in San Marino in 2007 to that in 2009?
Your answer should be very brief. 1.08. What is the ratio of the Taxes (in $) in Singapore in 2007 to that in 2009?
Your response must be concise. 0.87. What is the ratio of the Taxes (in $) in Tunisia in 2007 to that in 2009?
Your answer should be very brief. 0.8. What is the ratio of the Taxes (in $) in Netherlands in 2007 to that in 2010?
Provide a succinct answer. 0.98. What is the ratio of the Taxes (in $) in San Marino in 2007 to that in 2010?
Offer a very short reply. 1.27. What is the ratio of the Taxes (in $) of Singapore in 2007 to that in 2010?
Your answer should be very brief. 0.8. What is the ratio of the Taxes (in $) of Tunisia in 2007 to that in 2010?
Make the answer very short. 0.73. What is the ratio of the Taxes (in $) of Netherlands in 2008 to that in 2009?
Make the answer very short. 1.03. What is the ratio of the Taxes (in $) in San Marino in 2008 to that in 2009?
Keep it short and to the point. 1.11. What is the ratio of the Taxes (in $) of Singapore in 2008 to that in 2009?
Keep it short and to the point. 1.12. What is the ratio of the Taxes (in $) in Tunisia in 2008 to that in 2009?
Your answer should be compact. 0.98. What is the ratio of the Taxes (in $) of San Marino in 2008 to that in 2010?
Give a very brief answer. 1.32. What is the ratio of the Taxes (in $) in Singapore in 2008 to that in 2010?
Offer a very short reply. 1.03. What is the ratio of the Taxes (in $) in Tunisia in 2008 to that in 2010?
Your answer should be very brief. 0.91. What is the ratio of the Taxes (in $) in Netherlands in 2009 to that in 2010?
Provide a succinct answer. 0.97. What is the ratio of the Taxes (in $) in San Marino in 2009 to that in 2010?
Offer a terse response. 1.18. What is the ratio of the Taxes (in $) of Singapore in 2009 to that in 2010?
Keep it short and to the point. 0.92. What is the difference between the highest and the second highest Taxes (in $) in Netherlands?
Offer a terse response. 1.63e+08. What is the difference between the highest and the second highest Taxes (in $) of San Marino?
Keep it short and to the point. 3.65e+06. What is the difference between the highest and the second highest Taxes (in $) of Singapore?
Your answer should be very brief. 6.11e+08. What is the difference between the highest and the second highest Taxes (in $) in Tunisia?
Keep it short and to the point. 3.87e+08. What is the difference between the highest and the lowest Taxes (in $) in Netherlands?
Your response must be concise. 1.78e+1. What is the difference between the highest and the lowest Taxes (in $) in San Marino?
Offer a terse response. 2.64e+07. What is the difference between the highest and the lowest Taxes (in $) in Singapore?
Give a very brief answer. 9.19e+09. What is the difference between the highest and the lowest Taxes (in $) in Tunisia?
Give a very brief answer. 2.65e+09. 